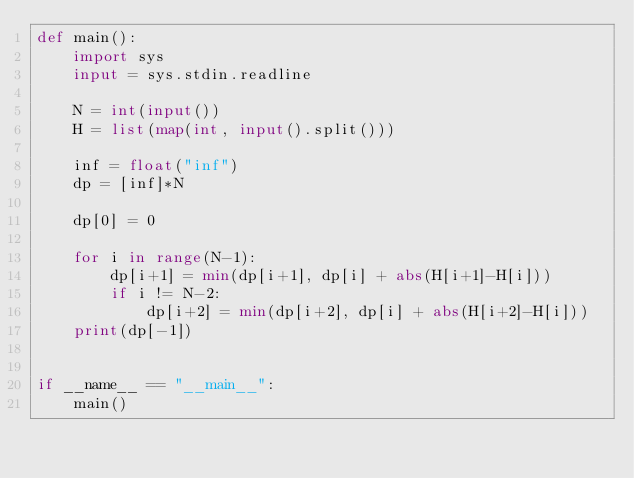Convert code to text. <code><loc_0><loc_0><loc_500><loc_500><_Python_>def main():
    import sys
    input = sys.stdin.readline

    N = int(input())
    H = list(map(int, input().split()))

    inf = float("inf")
    dp = [inf]*N

    dp[0] = 0

    for i in range(N-1):
        dp[i+1] = min(dp[i+1], dp[i] + abs(H[i+1]-H[i]))
        if i != N-2:
            dp[i+2] = min(dp[i+2], dp[i] + abs(H[i+2]-H[i]))
    print(dp[-1])


if __name__ == "__main__":
    main()
</code> 